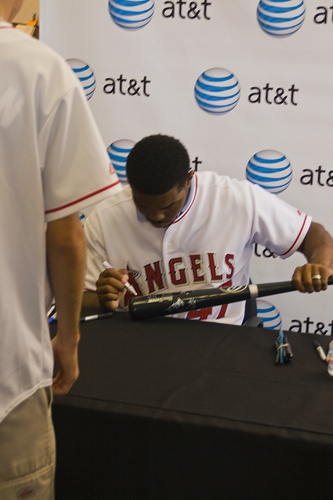Describe the objects in this image and their specific colors. I can see people in tan, darkgray, gray, and maroon tones, people in tan, darkgray, black, and lightgray tones, and baseball bat in tan, black, and gray tones in this image. 